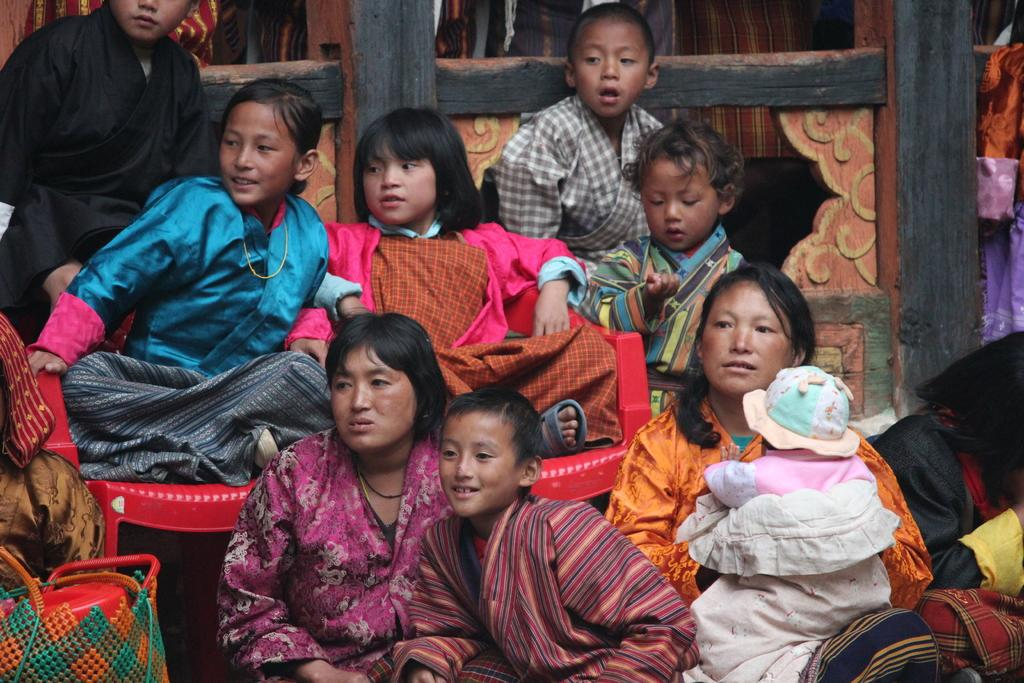What are the people in the image doing? The people in the image are sitting in the center. Can you describe the age group of the people in the image? There are babies present in the image. What type of furniture is visible in the image? Chairs are visible in the image. What can be seen in the background of the image? There is a fence in the background of the image. How many cattle can be seen grazing in the image? There are no cattle present in the image. What is the duration of the event happening in the image, measured in minutes? The image does not provide information about the duration of any event, and there is no mention of time in minutes. 